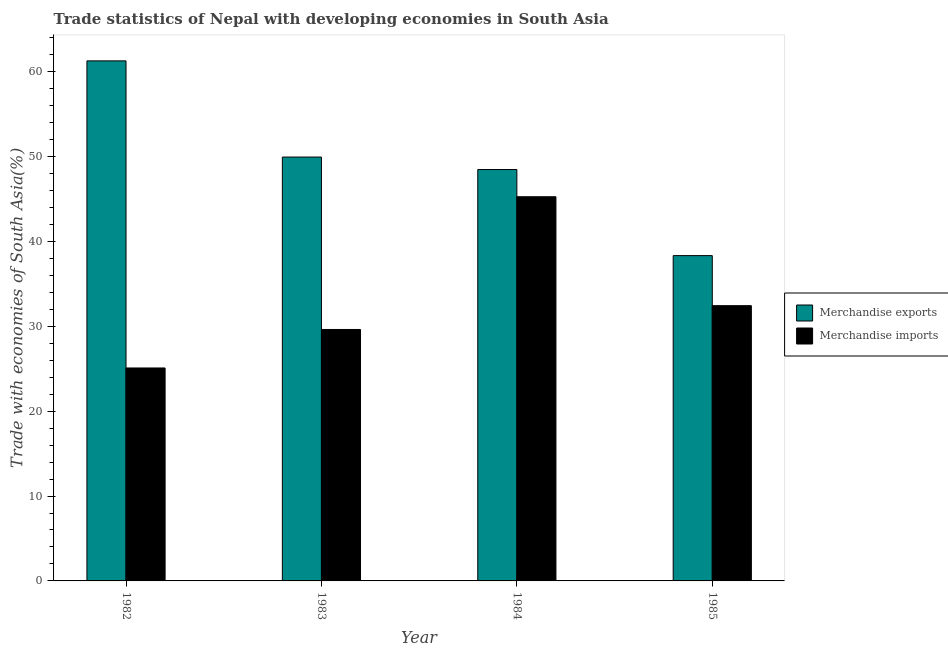How many different coloured bars are there?
Your response must be concise. 2. How many bars are there on the 1st tick from the left?
Make the answer very short. 2. What is the label of the 3rd group of bars from the left?
Offer a terse response. 1984. In how many cases, is the number of bars for a given year not equal to the number of legend labels?
Offer a very short reply. 0. What is the merchandise imports in 1985?
Ensure brevity in your answer.  32.43. Across all years, what is the maximum merchandise imports?
Your answer should be very brief. 45.25. Across all years, what is the minimum merchandise exports?
Provide a short and direct response. 38.32. In which year was the merchandise exports minimum?
Offer a terse response. 1985. What is the total merchandise imports in the graph?
Offer a very short reply. 132.38. What is the difference between the merchandise exports in 1982 and that in 1983?
Keep it short and to the point. 11.33. What is the difference between the merchandise imports in 1985 and the merchandise exports in 1984?
Offer a terse response. -12.83. What is the average merchandise exports per year?
Provide a succinct answer. 49.49. In how many years, is the merchandise exports greater than 58 %?
Your response must be concise. 1. What is the ratio of the merchandise exports in 1983 to that in 1985?
Your response must be concise. 1.3. Is the difference between the merchandise imports in 1983 and 1984 greater than the difference between the merchandise exports in 1983 and 1984?
Your response must be concise. No. What is the difference between the highest and the second highest merchandise exports?
Keep it short and to the point. 11.33. What is the difference between the highest and the lowest merchandise imports?
Your answer should be very brief. 20.17. How many bars are there?
Make the answer very short. 8. What is the difference between two consecutive major ticks on the Y-axis?
Your answer should be very brief. 10. Does the graph contain any zero values?
Ensure brevity in your answer.  No. Does the graph contain grids?
Make the answer very short. No. How many legend labels are there?
Make the answer very short. 2. What is the title of the graph?
Make the answer very short. Trade statistics of Nepal with developing economies in South Asia. What is the label or title of the X-axis?
Your answer should be compact. Year. What is the label or title of the Y-axis?
Your answer should be compact. Trade with economies of South Asia(%). What is the Trade with economies of South Asia(%) in Merchandise exports in 1982?
Your response must be concise. 61.26. What is the Trade with economies of South Asia(%) in Merchandise imports in 1982?
Offer a very short reply. 25.08. What is the Trade with economies of South Asia(%) of Merchandise exports in 1983?
Give a very brief answer. 49.93. What is the Trade with economies of South Asia(%) in Merchandise imports in 1983?
Make the answer very short. 29.62. What is the Trade with economies of South Asia(%) in Merchandise exports in 1984?
Your answer should be very brief. 48.46. What is the Trade with economies of South Asia(%) of Merchandise imports in 1984?
Ensure brevity in your answer.  45.25. What is the Trade with economies of South Asia(%) in Merchandise exports in 1985?
Your answer should be compact. 38.32. What is the Trade with economies of South Asia(%) of Merchandise imports in 1985?
Give a very brief answer. 32.43. Across all years, what is the maximum Trade with economies of South Asia(%) of Merchandise exports?
Provide a succinct answer. 61.26. Across all years, what is the maximum Trade with economies of South Asia(%) of Merchandise imports?
Offer a terse response. 45.25. Across all years, what is the minimum Trade with economies of South Asia(%) in Merchandise exports?
Offer a very short reply. 38.32. Across all years, what is the minimum Trade with economies of South Asia(%) in Merchandise imports?
Make the answer very short. 25.08. What is the total Trade with economies of South Asia(%) in Merchandise exports in the graph?
Provide a succinct answer. 197.97. What is the total Trade with economies of South Asia(%) of Merchandise imports in the graph?
Ensure brevity in your answer.  132.38. What is the difference between the Trade with economies of South Asia(%) in Merchandise exports in 1982 and that in 1983?
Keep it short and to the point. 11.33. What is the difference between the Trade with economies of South Asia(%) in Merchandise imports in 1982 and that in 1983?
Your response must be concise. -4.53. What is the difference between the Trade with economies of South Asia(%) of Merchandise exports in 1982 and that in 1984?
Provide a short and direct response. 12.8. What is the difference between the Trade with economies of South Asia(%) in Merchandise imports in 1982 and that in 1984?
Make the answer very short. -20.17. What is the difference between the Trade with economies of South Asia(%) of Merchandise exports in 1982 and that in 1985?
Offer a terse response. 22.94. What is the difference between the Trade with economies of South Asia(%) of Merchandise imports in 1982 and that in 1985?
Your answer should be compact. -7.34. What is the difference between the Trade with economies of South Asia(%) of Merchandise exports in 1983 and that in 1984?
Ensure brevity in your answer.  1.47. What is the difference between the Trade with economies of South Asia(%) of Merchandise imports in 1983 and that in 1984?
Give a very brief answer. -15.63. What is the difference between the Trade with economies of South Asia(%) in Merchandise exports in 1983 and that in 1985?
Offer a very short reply. 11.61. What is the difference between the Trade with economies of South Asia(%) in Merchandise imports in 1983 and that in 1985?
Make the answer very short. -2.81. What is the difference between the Trade with economies of South Asia(%) of Merchandise exports in 1984 and that in 1985?
Make the answer very short. 10.14. What is the difference between the Trade with economies of South Asia(%) of Merchandise imports in 1984 and that in 1985?
Offer a terse response. 12.83. What is the difference between the Trade with economies of South Asia(%) of Merchandise exports in 1982 and the Trade with economies of South Asia(%) of Merchandise imports in 1983?
Keep it short and to the point. 31.64. What is the difference between the Trade with economies of South Asia(%) of Merchandise exports in 1982 and the Trade with economies of South Asia(%) of Merchandise imports in 1984?
Keep it short and to the point. 16.01. What is the difference between the Trade with economies of South Asia(%) of Merchandise exports in 1982 and the Trade with economies of South Asia(%) of Merchandise imports in 1985?
Your answer should be very brief. 28.83. What is the difference between the Trade with economies of South Asia(%) in Merchandise exports in 1983 and the Trade with economies of South Asia(%) in Merchandise imports in 1984?
Ensure brevity in your answer.  4.68. What is the difference between the Trade with economies of South Asia(%) in Merchandise exports in 1983 and the Trade with economies of South Asia(%) in Merchandise imports in 1985?
Offer a very short reply. 17.51. What is the difference between the Trade with economies of South Asia(%) of Merchandise exports in 1984 and the Trade with economies of South Asia(%) of Merchandise imports in 1985?
Offer a very short reply. 16.03. What is the average Trade with economies of South Asia(%) in Merchandise exports per year?
Provide a succinct answer. 49.49. What is the average Trade with economies of South Asia(%) in Merchandise imports per year?
Your response must be concise. 33.1. In the year 1982, what is the difference between the Trade with economies of South Asia(%) of Merchandise exports and Trade with economies of South Asia(%) of Merchandise imports?
Provide a succinct answer. 36.17. In the year 1983, what is the difference between the Trade with economies of South Asia(%) of Merchandise exports and Trade with economies of South Asia(%) of Merchandise imports?
Give a very brief answer. 20.31. In the year 1984, what is the difference between the Trade with economies of South Asia(%) in Merchandise exports and Trade with economies of South Asia(%) in Merchandise imports?
Give a very brief answer. 3.2. In the year 1985, what is the difference between the Trade with economies of South Asia(%) in Merchandise exports and Trade with economies of South Asia(%) in Merchandise imports?
Make the answer very short. 5.89. What is the ratio of the Trade with economies of South Asia(%) of Merchandise exports in 1982 to that in 1983?
Provide a succinct answer. 1.23. What is the ratio of the Trade with economies of South Asia(%) in Merchandise imports in 1982 to that in 1983?
Provide a short and direct response. 0.85. What is the ratio of the Trade with economies of South Asia(%) of Merchandise exports in 1982 to that in 1984?
Ensure brevity in your answer.  1.26. What is the ratio of the Trade with economies of South Asia(%) in Merchandise imports in 1982 to that in 1984?
Provide a short and direct response. 0.55. What is the ratio of the Trade with economies of South Asia(%) in Merchandise exports in 1982 to that in 1985?
Offer a very short reply. 1.6. What is the ratio of the Trade with economies of South Asia(%) in Merchandise imports in 1982 to that in 1985?
Offer a very short reply. 0.77. What is the ratio of the Trade with economies of South Asia(%) of Merchandise exports in 1983 to that in 1984?
Offer a terse response. 1.03. What is the ratio of the Trade with economies of South Asia(%) of Merchandise imports in 1983 to that in 1984?
Ensure brevity in your answer.  0.65. What is the ratio of the Trade with economies of South Asia(%) of Merchandise exports in 1983 to that in 1985?
Keep it short and to the point. 1.3. What is the ratio of the Trade with economies of South Asia(%) of Merchandise imports in 1983 to that in 1985?
Your answer should be very brief. 0.91. What is the ratio of the Trade with economies of South Asia(%) in Merchandise exports in 1984 to that in 1985?
Provide a short and direct response. 1.26. What is the ratio of the Trade with economies of South Asia(%) in Merchandise imports in 1984 to that in 1985?
Provide a succinct answer. 1.4. What is the difference between the highest and the second highest Trade with economies of South Asia(%) in Merchandise exports?
Offer a terse response. 11.33. What is the difference between the highest and the second highest Trade with economies of South Asia(%) of Merchandise imports?
Give a very brief answer. 12.83. What is the difference between the highest and the lowest Trade with economies of South Asia(%) of Merchandise exports?
Ensure brevity in your answer.  22.94. What is the difference between the highest and the lowest Trade with economies of South Asia(%) of Merchandise imports?
Provide a short and direct response. 20.17. 